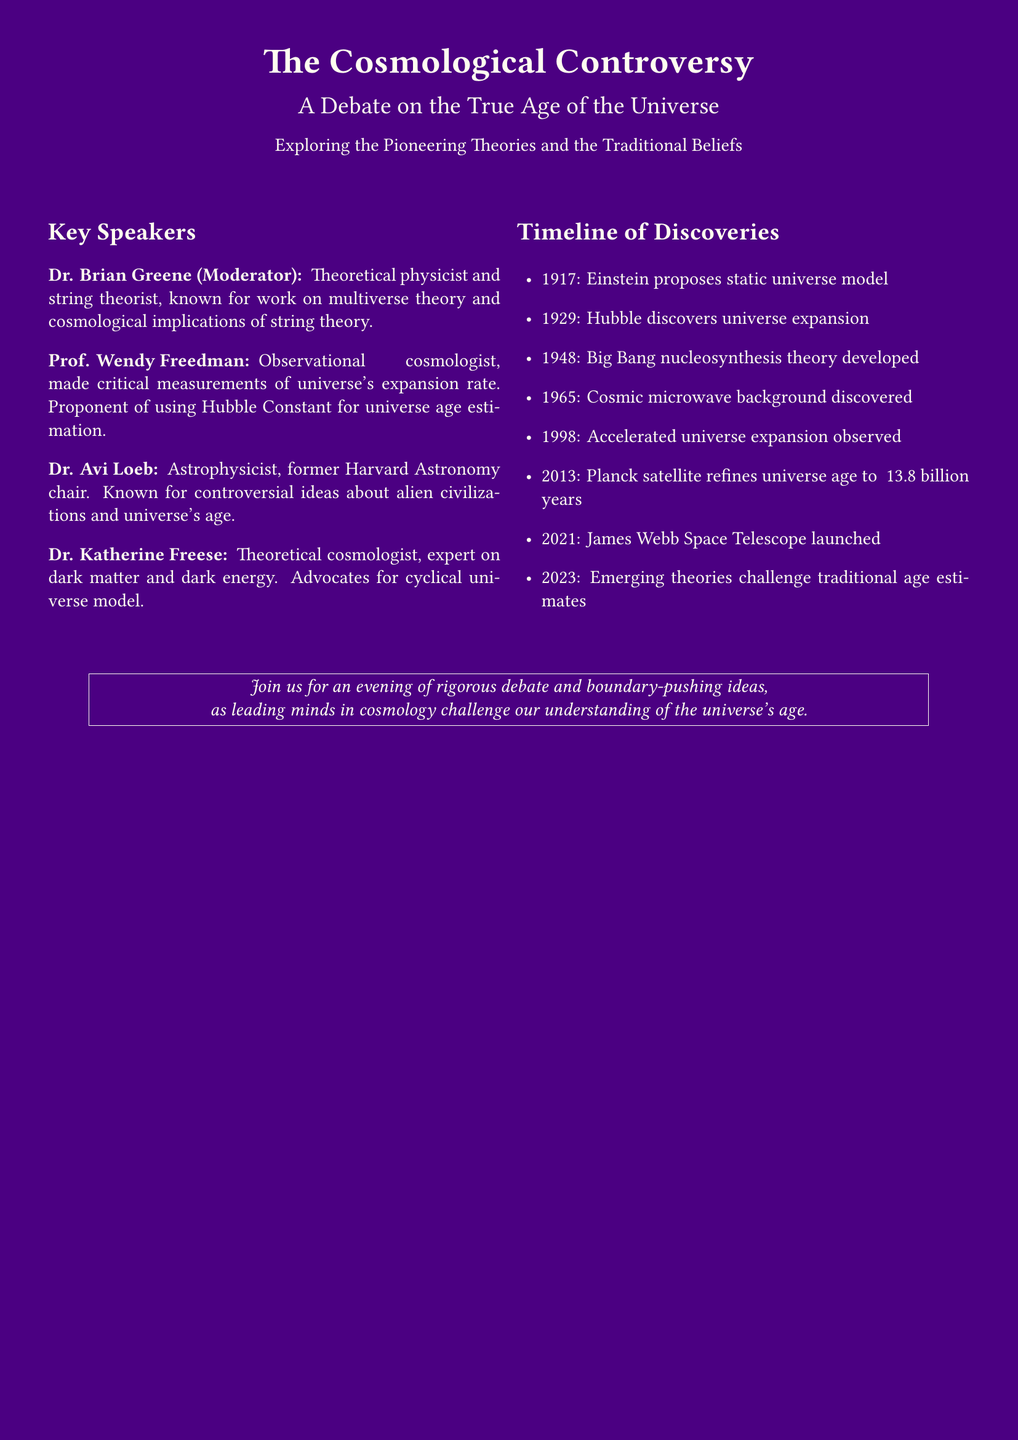What is the title of the event? The title of the event is "The Cosmological Controversy."
Answer: The Cosmological Controversy Who is the moderator of the debate? The moderator of the debate is Dr. Brian Greene.
Answer: Dr. Brian Greene What year was the Cosmic microwave background discovered? The document specifies that the Cosmic microwave background was discovered in 1965.
Answer: 1965 Which telescope was launched in 2021? The document states that the James Webb Space Telescope was launched in 2021.
Answer: James Webb Space Telescope What theory does Dr. Katherine Freese advocate for? Dr. Katherine Freese advocates for the cyclical universe model.
Answer: cyclical universe model When was the Big Bang nucleosynthesis theory developed? According to the timeline, the Big Bang nucleosynthesis theory was developed in 1948.
Answer: 1948 What discovery in 1998 was related to the universe's expansion? The document indicates that accelerated universe expansion was observed in 1998.
Answer: accelerated universe expansion Who is known for controversial ideas about alien civilizations? Dr. Avi Loeb is known for controversial ideas about alien civilizations.
Answer: Dr. Avi Loeb What is the main theme of the evening event described in the document? The main theme of the evening event is a debate on the true age of the universe.
Answer: true age of the universe 